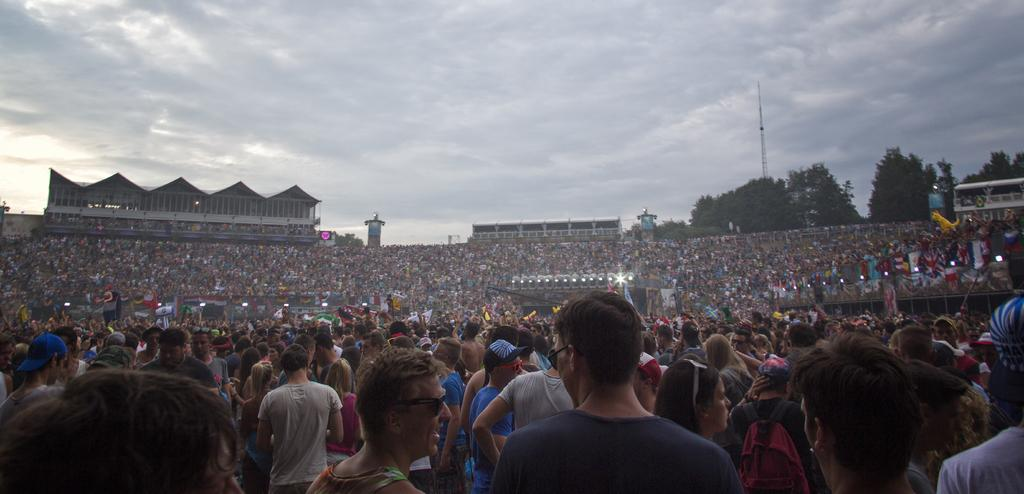How many people are present in the image? There are many people in the image. What is the main feature at the center of the image? There is a stage at the center of the image. What can be seen on the stage? The stage has lights. What can be seen in the background of the image? There are trees, buildings, and an electric pole in the background of the image. Are there any slaves depicted in the image? There is no mention of slaves or any related context in the image. How does the show on the stage end in the image? The image does not depict the end of the show or any specific event taking place on the stage. 